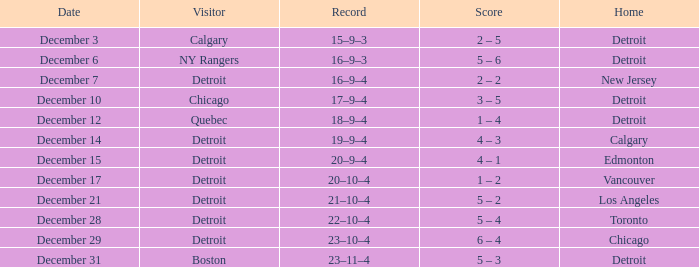Who is the visitor on december 3? Calgary. 